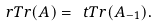<formula> <loc_0><loc_0><loc_500><loc_500>\ r T r ( A ) = \ t T r ( A _ { - 1 } ) .</formula> 